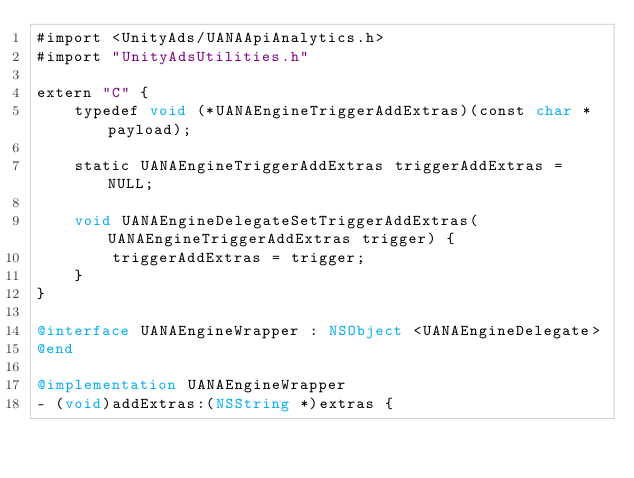<code> <loc_0><loc_0><loc_500><loc_500><_ObjectiveC_>#import <UnityAds/UANAApiAnalytics.h>
#import "UnityAdsUtilities.h"

extern "C" {
    typedef void (*UANAEngineTriggerAddExtras)(const char *payload);

    static UANAEngineTriggerAddExtras triggerAddExtras = NULL;

    void UANAEngineDelegateSetTriggerAddExtras(UANAEngineTriggerAddExtras trigger) {
        triggerAddExtras = trigger;
    }
}

@interface UANAEngineWrapper : NSObject <UANAEngineDelegate>
@end

@implementation UANAEngineWrapper
- (void)addExtras:(NSString *)extras {</code> 